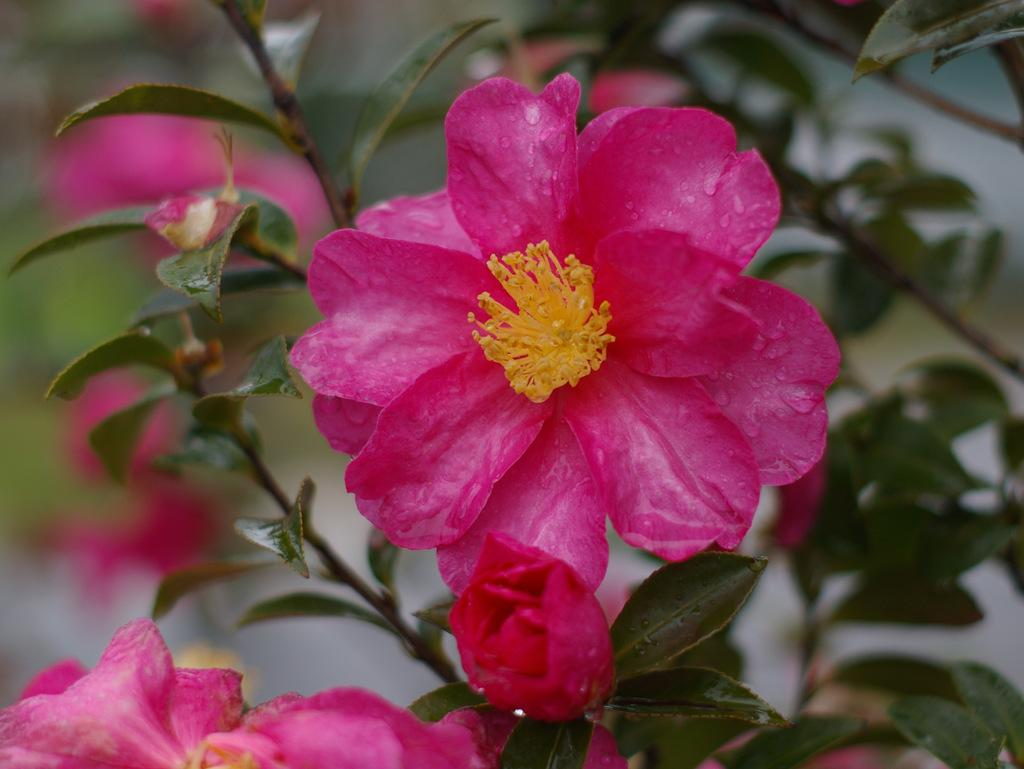What type of plant is visible in the image? The image features a plant with flowers on its stems. Can you describe the flowers on the plant? The flowers are visible on the stems of the plant. What type of pollution can be seen affecting the heart of the plant in the image? There is no pollution or heart present in the image; it features a plant with flowers on its stems. 